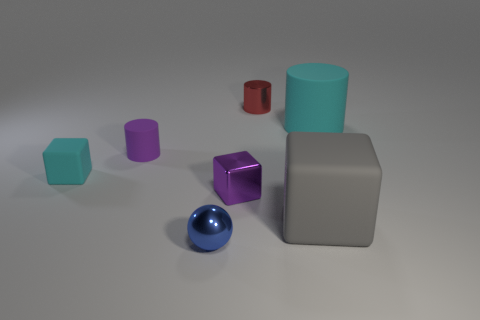Is the number of blue objects less than the number of big cyan metallic things?
Make the answer very short. No. Is the size of the blue sphere the same as the rubber block that is behind the large gray matte block?
Your response must be concise. Yes. What number of metal things are big gray objects or large blue cylinders?
Offer a terse response. 0. Are there more small blue spheres than brown matte balls?
Your response must be concise. Yes. The matte object that is the same color as the large cylinder is what size?
Make the answer very short. Small. The cyan object that is on the right side of the small thing that is left of the purple cylinder is what shape?
Offer a terse response. Cylinder. Is there a blue thing that is behind the cyan object that is on the left side of the tiny cylinder that is behind the cyan cylinder?
Keep it short and to the point. No. What is the color of the sphere that is the same size as the purple shiny block?
Make the answer very short. Blue. The small shiny object that is in front of the small cyan object and behind the gray cube has what shape?
Give a very brief answer. Cube. What is the size of the rubber cylinder that is left of the big object to the right of the gray cube?
Offer a very short reply. Small. 